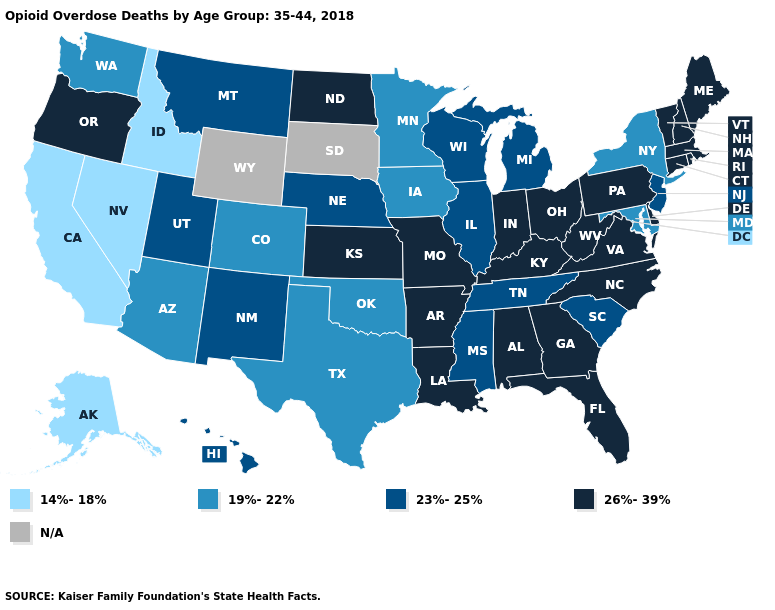Is the legend a continuous bar?
Give a very brief answer. No. Among the states that border Wyoming , which have the highest value?
Write a very short answer. Montana, Nebraska, Utah. Name the states that have a value in the range 14%-18%?
Write a very short answer. Alaska, California, Idaho, Nevada. What is the value of Nebraska?
Give a very brief answer. 23%-25%. Name the states that have a value in the range 23%-25%?
Quick response, please. Hawaii, Illinois, Michigan, Mississippi, Montana, Nebraska, New Jersey, New Mexico, South Carolina, Tennessee, Utah, Wisconsin. Among the states that border Tennessee , which have the highest value?
Answer briefly. Alabama, Arkansas, Georgia, Kentucky, Missouri, North Carolina, Virginia. Which states have the lowest value in the Northeast?
Write a very short answer. New York. Which states have the lowest value in the USA?
Short answer required. Alaska, California, Idaho, Nevada. Name the states that have a value in the range 26%-39%?
Quick response, please. Alabama, Arkansas, Connecticut, Delaware, Florida, Georgia, Indiana, Kansas, Kentucky, Louisiana, Maine, Massachusetts, Missouri, New Hampshire, North Carolina, North Dakota, Ohio, Oregon, Pennsylvania, Rhode Island, Vermont, Virginia, West Virginia. Name the states that have a value in the range 26%-39%?
Give a very brief answer. Alabama, Arkansas, Connecticut, Delaware, Florida, Georgia, Indiana, Kansas, Kentucky, Louisiana, Maine, Massachusetts, Missouri, New Hampshire, North Carolina, North Dakota, Ohio, Oregon, Pennsylvania, Rhode Island, Vermont, Virginia, West Virginia. What is the value of Wisconsin?
Give a very brief answer. 23%-25%. What is the value of Iowa?
Keep it brief. 19%-22%. What is the lowest value in the USA?
Short answer required. 14%-18%. 